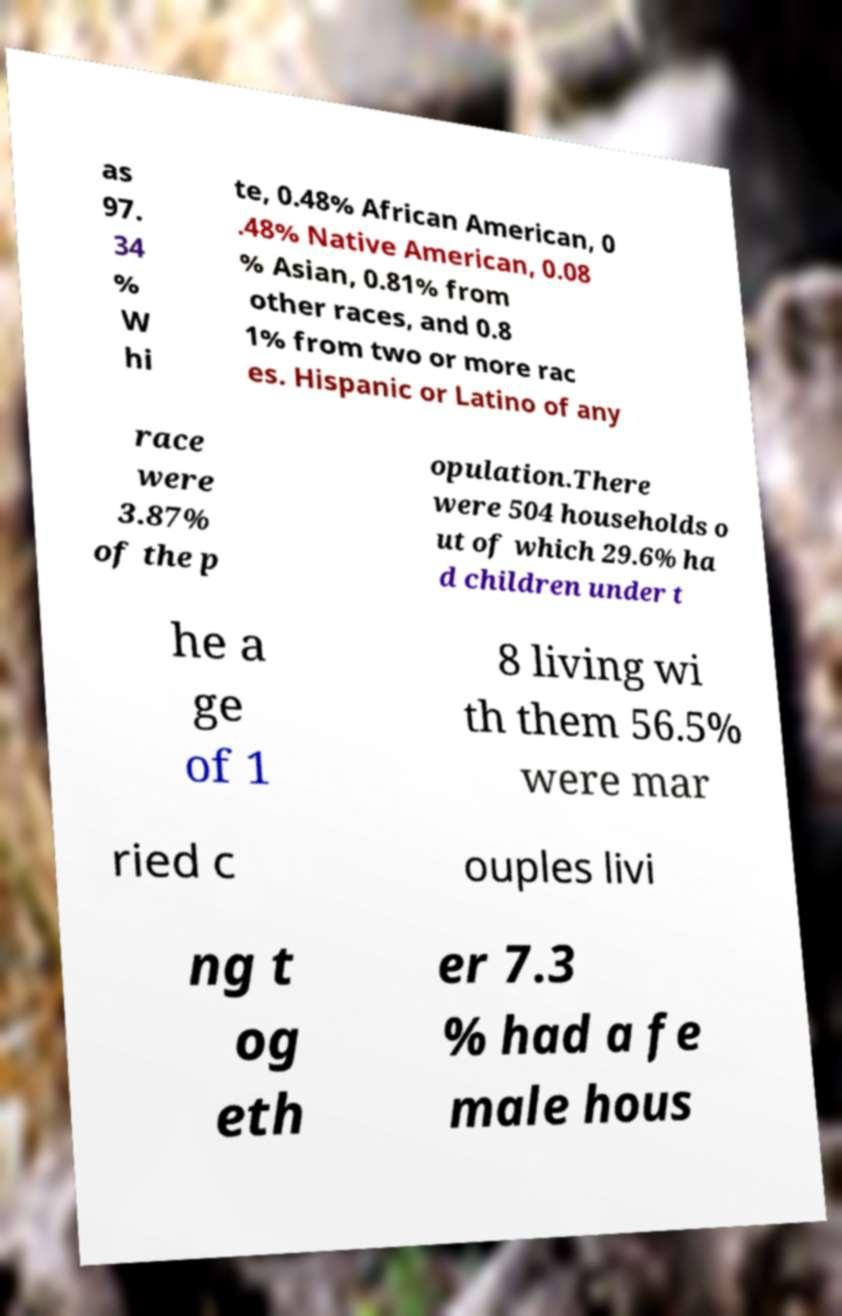Can you accurately transcribe the text from the provided image for me? as 97. 34 % W hi te, 0.48% African American, 0 .48% Native American, 0.08 % Asian, 0.81% from other races, and 0.8 1% from two or more rac es. Hispanic or Latino of any race were 3.87% of the p opulation.There were 504 households o ut of which 29.6% ha d children under t he a ge of 1 8 living wi th them 56.5% were mar ried c ouples livi ng t og eth er 7.3 % had a fe male hous 